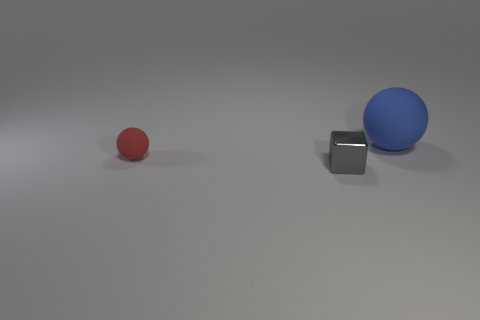Subtract all blue spheres. Subtract all cyan cylinders. How many spheres are left? 1 Add 3 gray cubes. How many objects exist? 6 Subtract all balls. How many objects are left? 1 Add 1 large matte balls. How many large matte balls are left? 2 Add 3 tiny red balls. How many tiny red balls exist? 4 Subtract 0 red cylinders. How many objects are left? 3 Subtract all tiny brown cubes. Subtract all rubber balls. How many objects are left? 1 